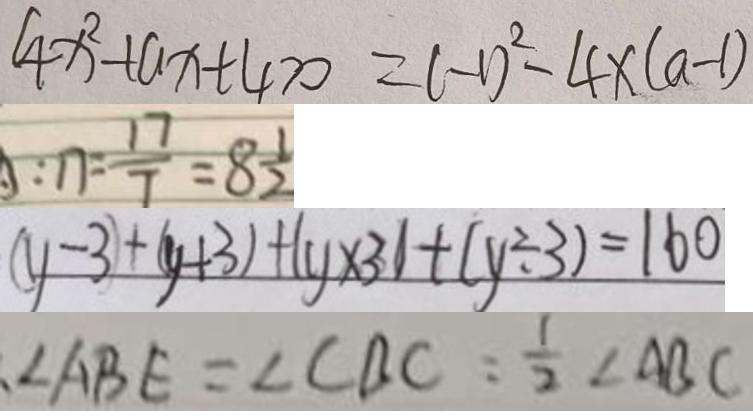<formula> <loc_0><loc_0><loc_500><loc_500>4 x ^ { 2 } + a x + 4 > 0 = ( - 1 ) ^ { 2 } - 4 x ( a - 1 ) 
 : 1 7 = \frac { 1 7 } { 7 } = 8 \frac { 1 } { 2 } 
 ( y - 3 ) + ( y + 3 ) + ( y \times 3 ) + ( y \div 3 ) = 1 6 0 
 \angle A B E = \angle C B C = \frac { 1 } { 2 } \angle A B C</formula> 